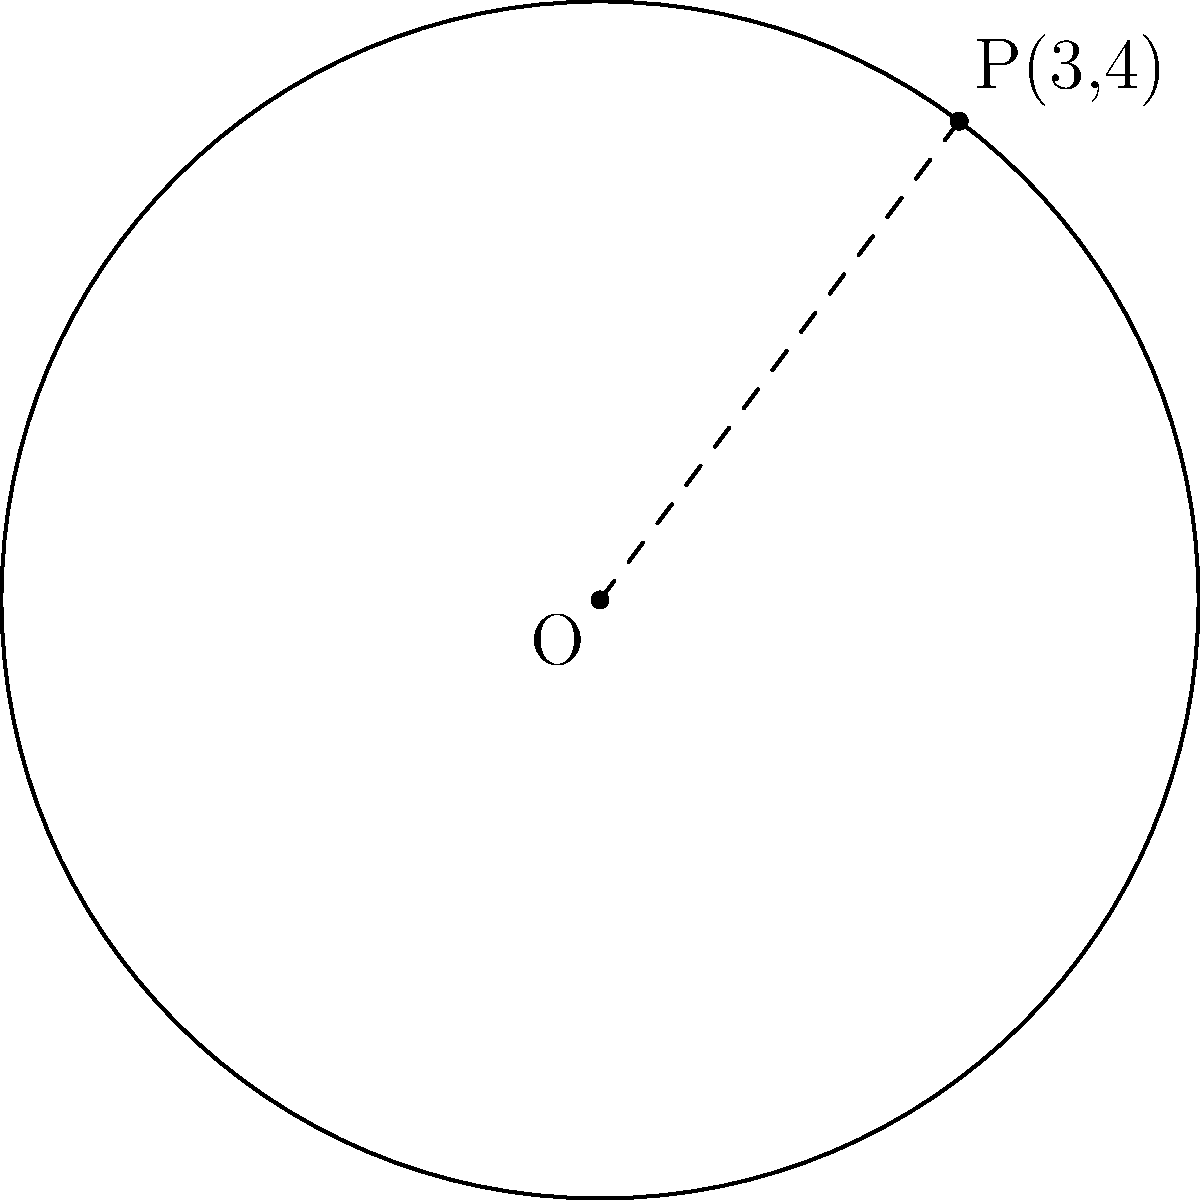In the diagram, O is the center of a circle, and P(3,4) is a point on its circumference. Determine the equation of this circle using the standard form $(x-h)^2 + (y-k)^2 = r^2$, where (h,k) is the center of the circle. To find the equation of the circle, we need to determine its center coordinates and radius.

Step 1: Identify the center
The center O is at the origin (0,0), so h = 0 and k = 0.

Step 2: Calculate the radius
The radius is the distance between the center O(0,0) and the point P(3,4).
Using the distance formula:
$r^2 = (x_2-x_1)^2 + (y_2-y_1)^2$
$r^2 = (3-0)^2 + (4-0)^2 = 3^2 + 4^2 = 9 + 16 = 25$

Step 3: Substitute into the standard form
$(x-h)^2 + (y-k)^2 = r^2$
$(x-0)^2 + (y-0)^2 = 25$

Step 4: Simplify
$x^2 + y^2 = 25$

This is the equation of the circle in its simplest form.
Answer: $x^2 + y^2 = 25$ 